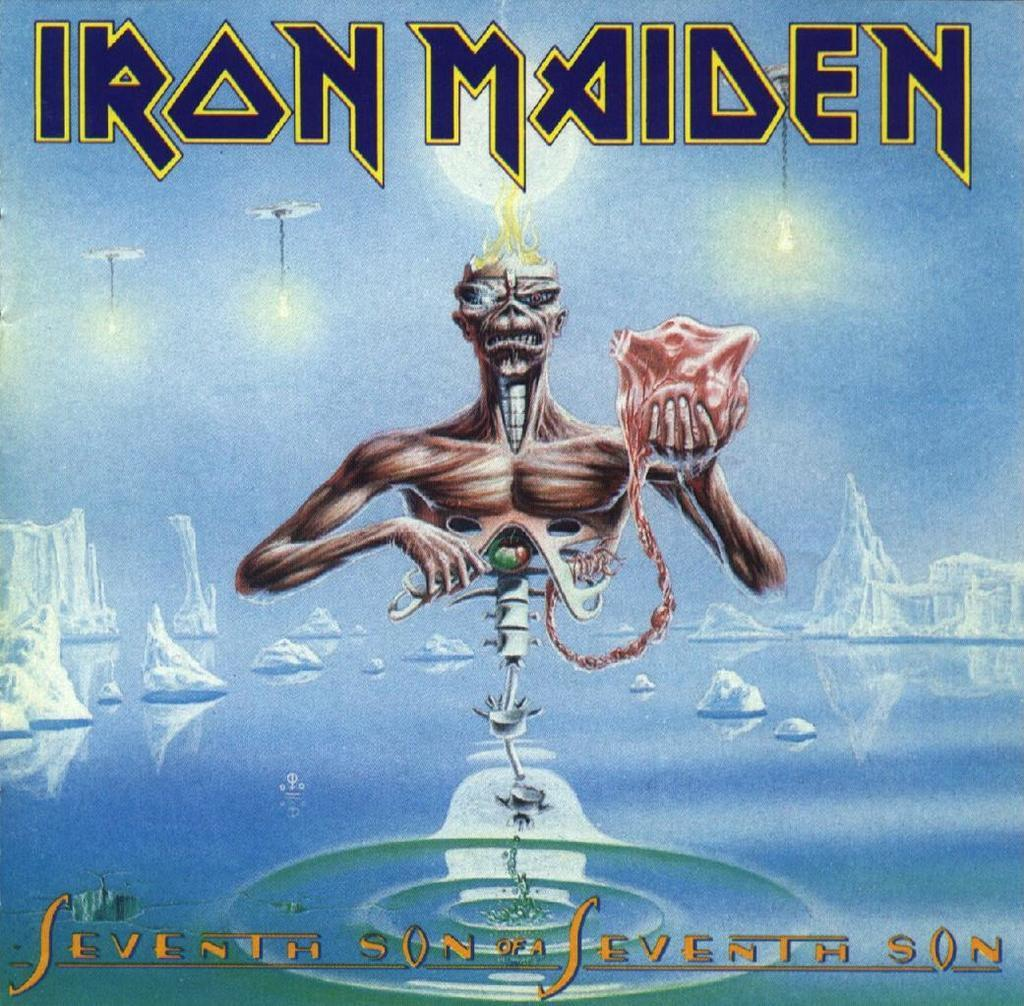What is present in the image that features an image? There is a poster in the image that contains an image. What is the subject of the image on the poster? The image depicts icebergs. Where is the text located on the poster? There is text on the top and bottom of the image. How many giants are visible in the image? There are no giants present in the image; it features a poster with an image of icebergs. What type of condition is affecting the cows in the image? There are no cows present in the image; it features a poster with an image of icebergs. 